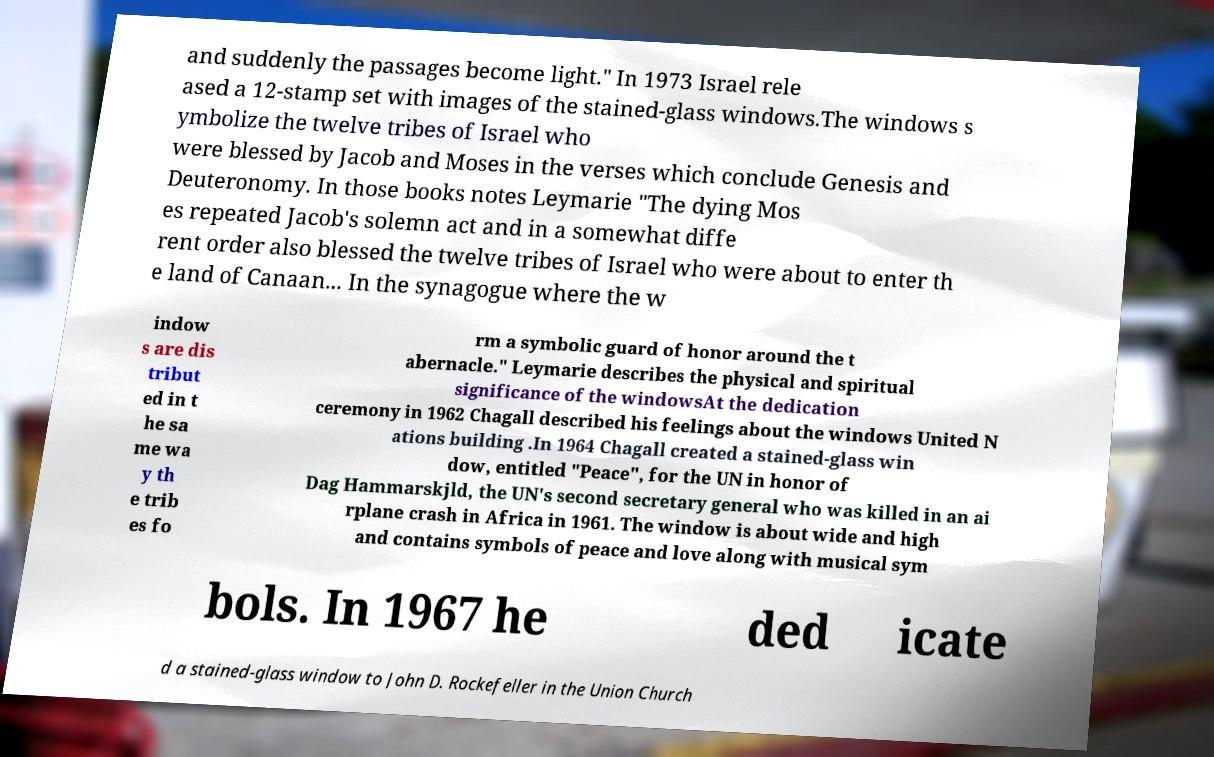Could you extract and type out the text from this image? and suddenly the passages become light." In 1973 Israel rele ased a 12-stamp set with images of the stained-glass windows.The windows s ymbolize the twelve tribes of Israel who were blessed by Jacob and Moses in the verses which conclude Genesis and Deuteronomy. In those books notes Leymarie "The dying Mos es repeated Jacob's solemn act and in a somewhat diffe rent order also blessed the twelve tribes of Israel who were about to enter th e land of Canaan... In the synagogue where the w indow s are dis tribut ed in t he sa me wa y th e trib es fo rm a symbolic guard of honor around the t abernacle." Leymarie describes the physical and spiritual significance of the windowsAt the dedication ceremony in 1962 Chagall described his feelings about the windows United N ations building .In 1964 Chagall created a stained-glass win dow, entitled "Peace", for the UN in honor of Dag Hammarskjld, the UN's second secretary general who was killed in an ai rplane crash in Africa in 1961. The window is about wide and high and contains symbols of peace and love along with musical sym bols. In 1967 he ded icate d a stained-glass window to John D. Rockefeller in the Union Church 